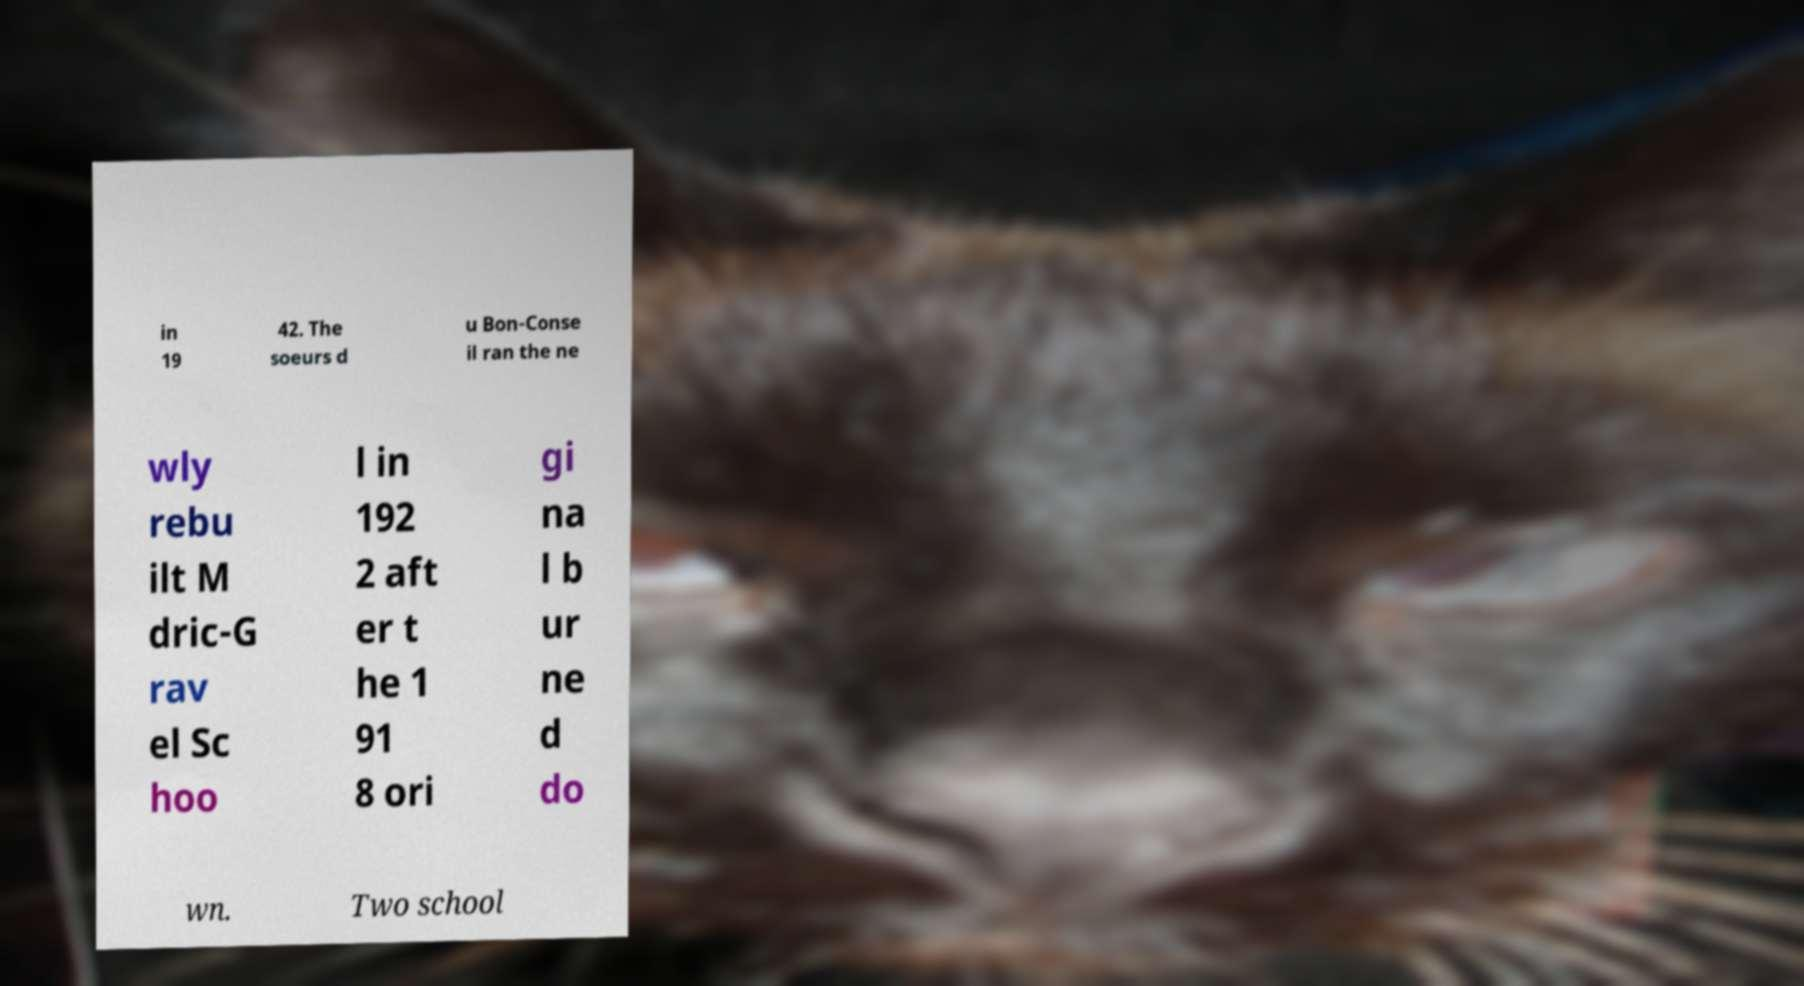Please read and relay the text visible in this image. What does it say? in 19 42. The soeurs d u Bon-Conse il ran the ne wly rebu ilt M dric-G rav el Sc hoo l in 192 2 aft er t he 1 91 8 ori gi na l b ur ne d do wn. Two school 